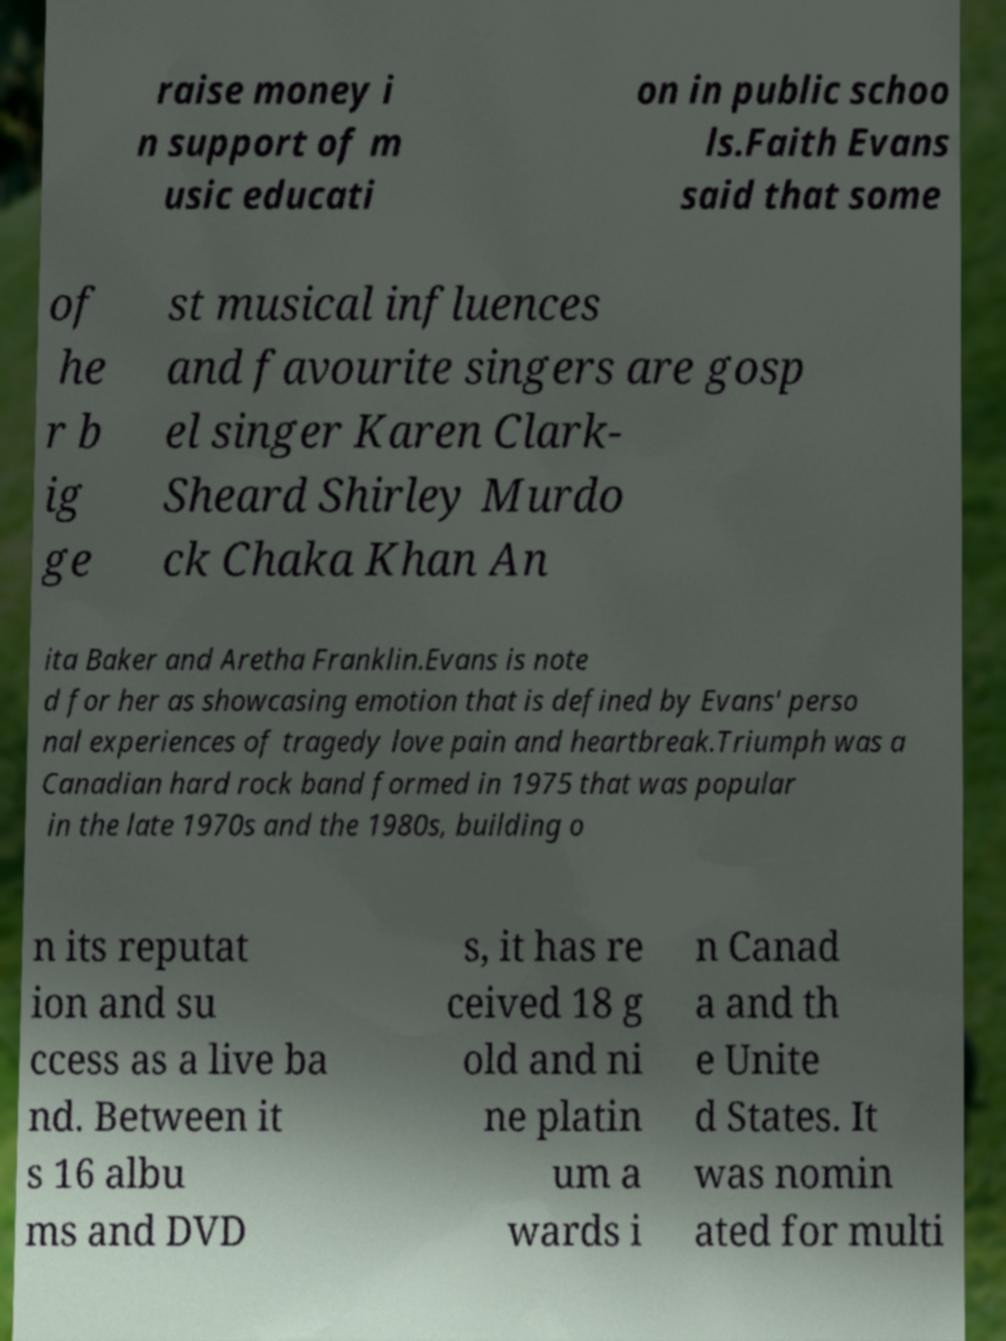Can you read and provide the text displayed in the image?This photo seems to have some interesting text. Can you extract and type it out for me? raise money i n support of m usic educati on in public schoo ls.Faith Evans said that some of he r b ig ge st musical influences and favourite singers are gosp el singer Karen Clark- Sheard Shirley Murdo ck Chaka Khan An ita Baker and Aretha Franklin.Evans is note d for her as showcasing emotion that is defined by Evans' perso nal experiences of tragedy love pain and heartbreak.Triumph was a Canadian hard rock band formed in 1975 that was popular in the late 1970s and the 1980s, building o n its reputat ion and su ccess as a live ba nd. Between it s 16 albu ms and DVD s, it has re ceived 18 g old and ni ne platin um a wards i n Canad a and th e Unite d States. It was nomin ated for multi 